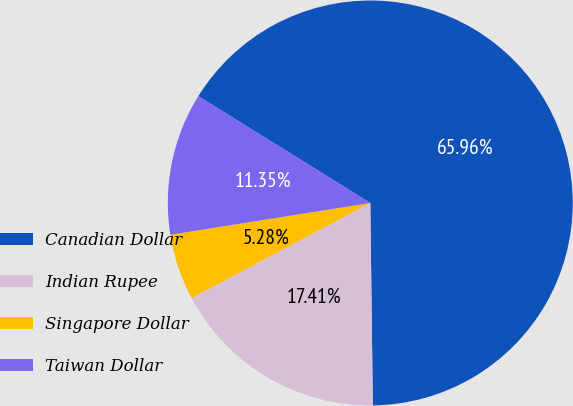Convert chart. <chart><loc_0><loc_0><loc_500><loc_500><pie_chart><fcel>Canadian Dollar<fcel>Indian Rupee<fcel>Singapore Dollar<fcel>Taiwan Dollar<nl><fcel>65.96%<fcel>17.41%<fcel>5.28%<fcel>11.35%<nl></chart> 